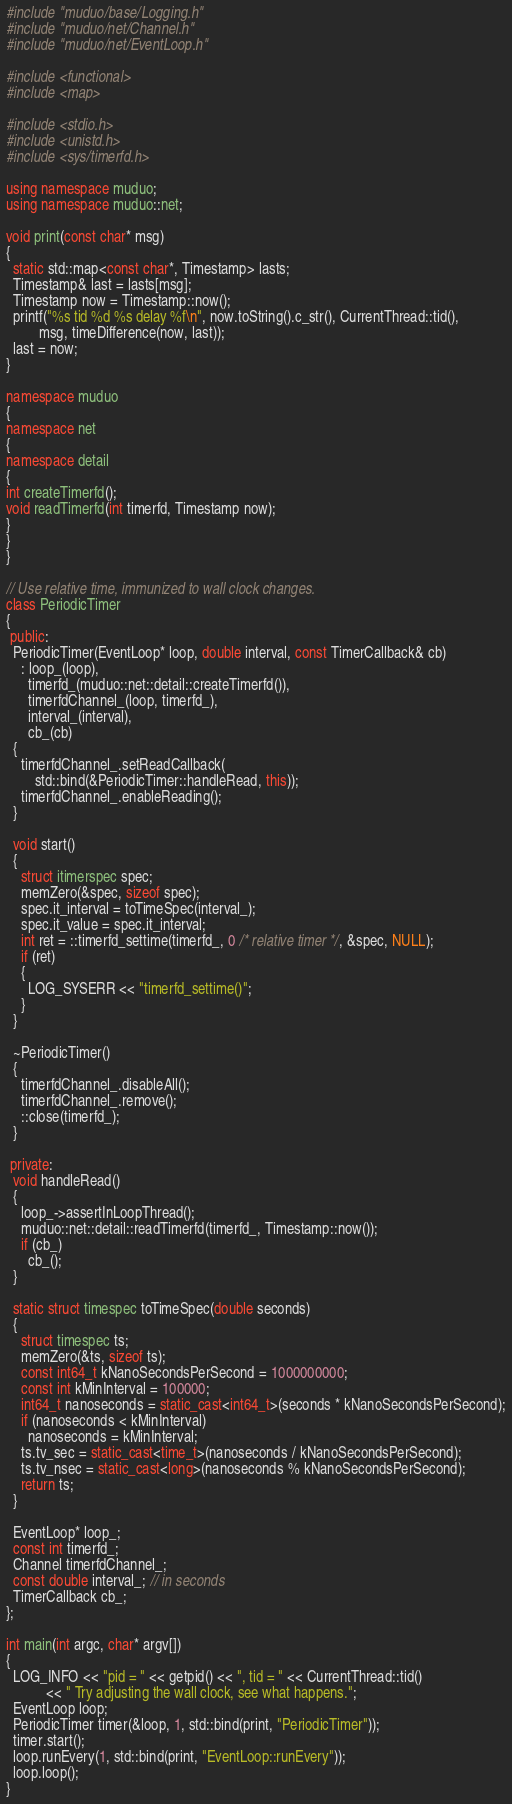<code> <loc_0><loc_0><loc_500><loc_500><_C++_>#include "muduo/base/Logging.h"
#include "muduo/net/Channel.h"
#include "muduo/net/EventLoop.h"

#include <functional>
#include <map>

#include <stdio.h>
#include <unistd.h>
#include <sys/timerfd.h>

using namespace muduo;
using namespace muduo::net;

void print(const char* msg)
{
  static std::map<const char*, Timestamp> lasts;
  Timestamp& last = lasts[msg];
  Timestamp now = Timestamp::now();
  printf("%s tid %d %s delay %f\n", now.toString().c_str(), CurrentThread::tid(),
         msg, timeDifference(now, last));
  last = now;
}

namespace muduo
{
namespace net
{
namespace detail
{
int createTimerfd();
void readTimerfd(int timerfd, Timestamp now);
}
}
}

// Use relative time, immunized to wall clock changes.
class PeriodicTimer
{
 public:
  PeriodicTimer(EventLoop* loop, double interval, const TimerCallback& cb)
    : loop_(loop),
      timerfd_(muduo::net::detail::createTimerfd()),
      timerfdChannel_(loop, timerfd_),
      interval_(interval),
      cb_(cb)
  {
    timerfdChannel_.setReadCallback(
        std::bind(&PeriodicTimer::handleRead, this));
    timerfdChannel_.enableReading();
  }

  void start()
  {
    struct itimerspec spec;
    memZero(&spec, sizeof spec);
    spec.it_interval = toTimeSpec(interval_);
    spec.it_value = spec.it_interval;
    int ret = ::timerfd_settime(timerfd_, 0 /* relative timer */, &spec, NULL);
    if (ret)
    {
      LOG_SYSERR << "timerfd_settime()";
    }
  }

  ~PeriodicTimer()
  {
    timerfdChannel_.disableAll();
    timerfdChannel_.remove();
    ::close(timerfd_);
  }

 private:
  void handleRead()
  {
    loop_->assertInLoopThread();
    muduo::net::detail::readTimerfd(timerfd_, Timestamp::now());
    if (cb_)
      cb_();
  }

  static struct timespec toTimeSpec(double seconds)
  {
    struct timespec ts;
    memZero(&ts, sizeof ts);
    const int64_t kNanoSecondsPerSecond = 1000000000;
    const int kMinInterval = 100000;
    int64_t nanoseconds = static_cast<int64_t>(seconds * kNanoSecondsPerSecond);
    if (nanoseconds < kMinInterval)
      nanoseconds = kMinInterval;
    ts.tv_sec = static_cast<time_t>(nanoseconds / kNanoSecondsPerSecond);
    ts.tv_nsec = static_cast<long>(nanoseconds % kNanoSecondsPerSecond);
    return ts;
  }

  EventLoop* loop_;
  const int timerfd_;
  Channel timerfdChannel_;
  const double interval_; // in seconds
  TimerCallback cb_;
};

int main(int argc, char* argv[])
{
  LOG_INFO << "pid = " << getpid() << ", tid = " << CurrentThread::tid()
           << " Try adjusting the wall clock, see what happens.";
  EventLoop loop;
  PeriodicTimer timer(&loop, 1, std::bind(print, "PeriodicTimer"));
  timer.start();
  loop.runEvery(1, std::bind(print, "EventLoop::runEvery"));
  loop.loop();
}
</code> 